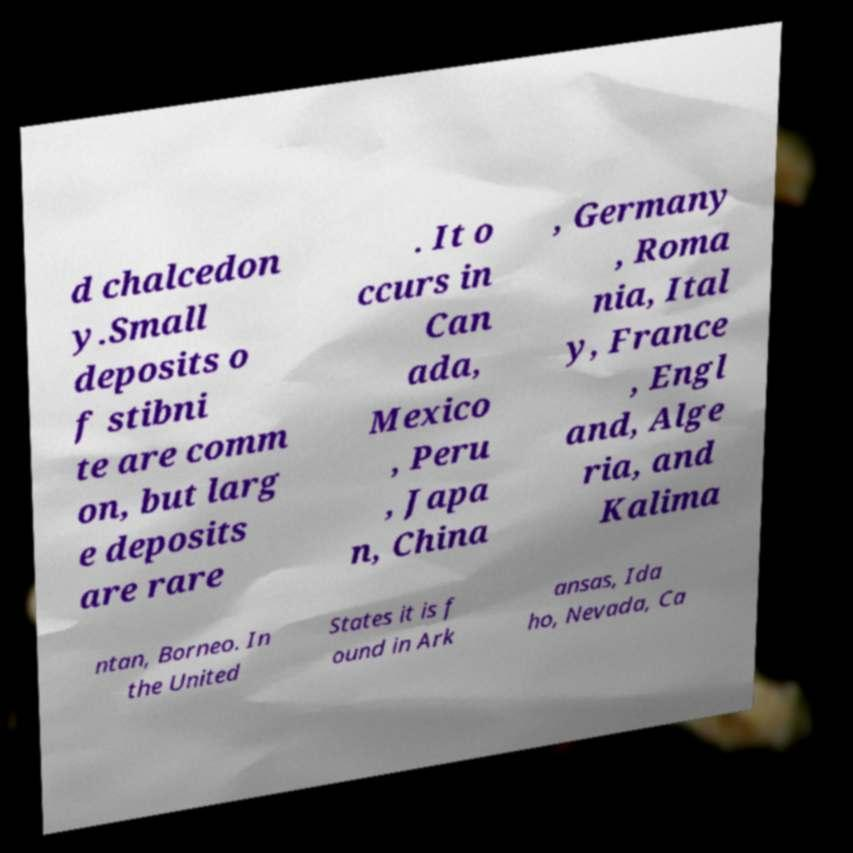Can you read and provide the text displayed in the image?This photo seems to have some interesting text. Can you extract and type it out for me? d chalcedon y.Small deposits o f stibni te are comm on, but larg e deposits are rare . It o ccurs in Can ada, Mexico , Peru , Japa n, China , Germany , Roma nia, Ital y, France , Engl and, Alge ria, and Kalima ntan, Borneo. In the United States it is f ound in Ark ansas, Ida ho, Nevada, Ca 